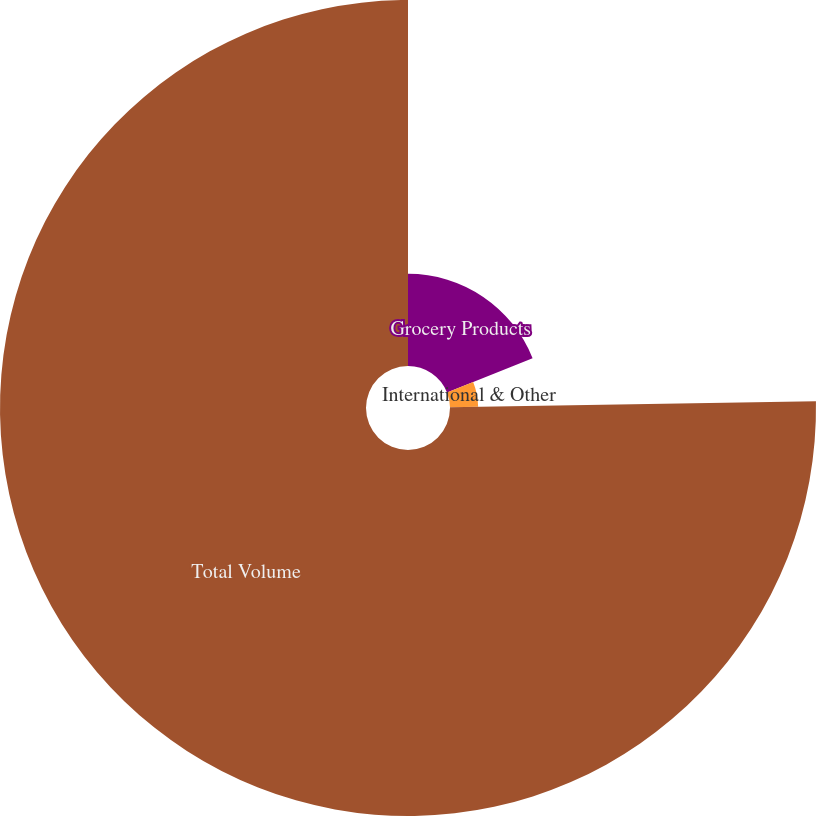Convert chart to OTSL. <chart><loc_0><loc_0><loc_500><loc_500><pie_chart><fcel>Grocery Products<fcel>International & Other<fcel>Total Volume<nl><fcel>18.95%<fcel>5.79%<fcel>75.26%<nl></chart> 